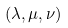<formula> <loc_0><loc_0><loc_500><loc_500>( \lambda , \mu , \nu )</formula> 